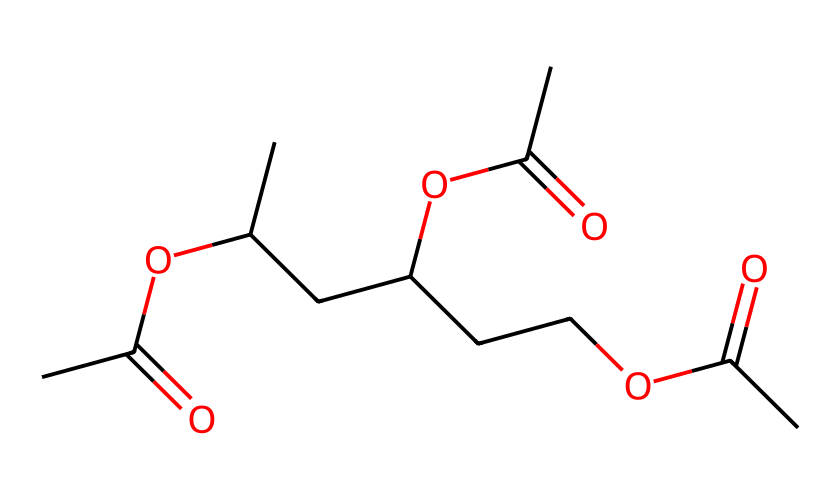What is the molecular formula of this compound? Analyzing the SMILES, we can deduce the number of each type of atom present. The structure indicates that for every carbon (C) and oxygen (O) connected, we can count them directly from the SMILES string. The result gives us C12H22O6.
Answer: C12H22O6 How many ester groups are present in this chemical structure? Looking into the SMILES, we can identify the sections that represent ester groups (OC(=O)). Each occurrence of this pattern corresponds to one ester group. In this case, there are 3 occurrences of the ester functional group.
Answer: 3 What type of bonding can be inferred from the structure? The structure predominantly features single bonds (between carbon atoms) and the presence of a -C(=O)O- (ester) suggests both covalent bonding within the backbone and between functional groups. Overall, predominantly covalent bonds are present.
Answer: covalent Does the chemical contain any five-membered rings? By examining the structure represented in the SMILES, we can observe that there are no cyclic structures or ring formations shown. All sections appear linear and branched. There are no five-membered rings in the compound.
Answer: no What kind of non-Newtonian behavior would you expect from this compound? Polyvinyl acetate is known for its viscoelastic properties, which means that under stress it exhibits both viscous and elastic characteristics. This typical behavior reflects its use in non-Newtonian fluids.
Answer: viscoelastic How many carbon atoms are in the longest carbon chain? By looking at how the carbon atoms are arranged in the SMILES representation, we can trace the longest continuous chain of carbon atoms. The longest chain comprises of 5 carbon atoms in a row.
Answer: 5 